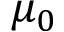Convert formula to latex. <formula><loc_0><loc_0><loc_500><loc_500>\mu _ { 0 }</formula> 